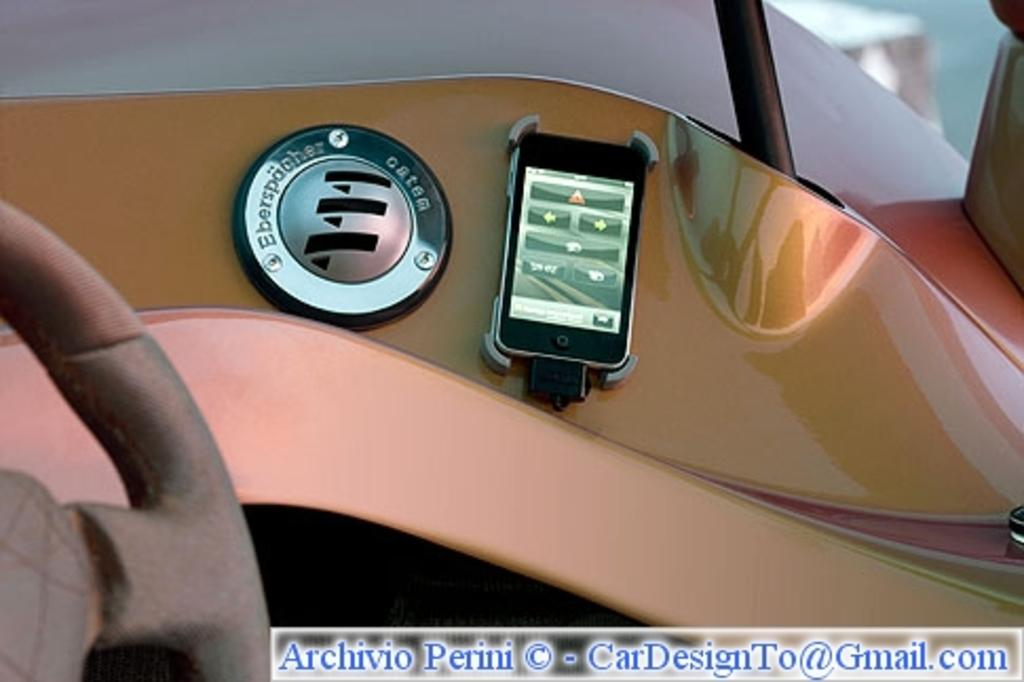What is the location of the person taking the image? The image is taken from inside a vehicle. What can be seen in the vehicle that is related to driving? There is a steering wheel in the image. What electronic device is present in the image? There is a mobile phone in the image. What type of controls are visible in the image? There are buttons in the image. What information is provided at the bottom of the image? There is some text at the bottom of the image. What type of fowl can be seen sitting on a bucket in the image? There is no fowl or bucket present in the image. How many stamps are visible on the steering wheel in the image? There are no stamps visible on the steering wheel in the image. 